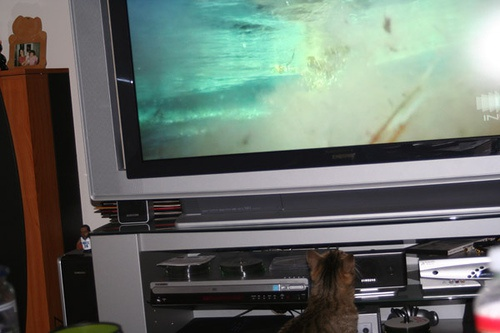Describe the objects in this image and their specific colors. I can see tv in gray, black, beige, and darkgray tones and cat in gray, black, and maroon tones in this image. 